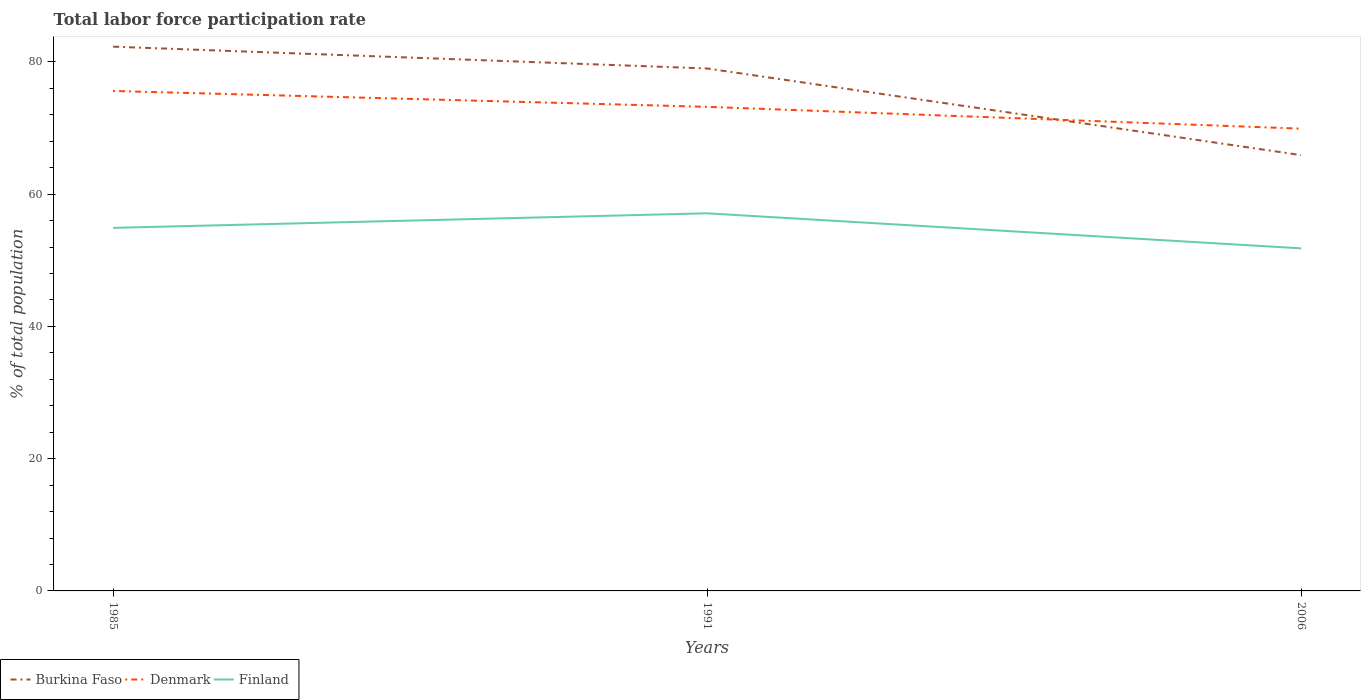Does the line corresponding to Burkina Faso intersect with the line corresponding to Finland?
Give a very brief answer. No. Across all years, what is the maximum total labor force participation rate in Finland?
Offer a very short reply. 51.8. In which year was the total labor force participation rate in Finland maximum?
Offer a very short reply. 2006. What is the total total labor force participation rate in Denmark in the graph?
Ensure brevity in your answer.  2.4. What is the difference between the highest and the second highest total labor force participation rate in Finland?
Provide a short and direct response. 5.3. Is the total labor force participation rate in Finland strictly greater than the total labor force participation rate in Denmark over the years?
Your answer should be very brief. Yes. What is the difference between two consecutive major ticks on the Y-axis?
Ensure brevity in your answer.  20. Does the graph contain grids?
Your response must be concise. No. Where does the legend appear in the graph?
Your answer should be compact. Bottom left. How many legend labels are there?
Your response must be concise. 3. How are the legend labels stacked?
Keep it short and to the point. Horizontal. What is the title of the graph?
Make the answer very short. Total labor force participation rate. What is the label or title of the Y-axis?
Give a very brief answer. % of total population. What is the % of total population of Burkina Faso in 1985?
Keep it short and to the point. 82.3. What is the % of total population of Denmark in 1985?
Give a very brief answer. 75.6. What is the % of total population of Finland in 1985?
Provide a short and direct response. 54.9. What is the % of total population in Burkina Faso in 1991?
Your answer should be very brief. 79. What is the % of total population in Denmark in 1991?
Your answer should be compact. 73.2. What is the % of total population of Finland in 1991?
Keep it short and to the point. 57.1. What is the % of total population of Burkina Faso in 2006?
Ensure brevity in your answer.  65.9. What is the % of total population in Denmark in 2006?
Keep it short and to the point. 69.9. What is the % of total population in Finland in 2006?
Provide a succinct answer. 51.8. Across all years, what is the maximum % of total population of Burkina Faso?
Your answer should be compact. 82.3. Across all years, what is the maximum % of total population in Denmark?
Provide a succinct answer. 75.6. Across all years, what is the maximum % of total population in Finland?
Provide a succinct answer. 57.1. Across all years, what is the minimum % of total population of Burkina Faso?
Provide a short and direct response. 65.9. Across all years, what is the minimum % of total population of Denmark?
Make the answer very short. 69.9. Across all years, what is the minimum % of total population in Finland?
Make the answer very short. 51.8. What is the total % of total population of Burkina Faso in the graph?
Offer a very short reply. 227.2. What is the total % of total population in Denmark in the graph?
Ensure brevity in your answer.  218.7. What is the total % of total population of Finland in the graph?
Your response must be concise. 163.8. What is the difference between the % of total population in Burkina Faso in 1985 and that in 1991?
Offer a terse response. 3.3. What is the difference between the % of total population in Burkina Faso in 1985 and that in 2006?
Your answer should be compact. 16.4. What is the difference between the % of total population of Denmark in 1985 and that in 2006?
Ensure brevity in your answer.  5.7. What is the difference between the % of total population in Finland in 1985 and that in 2006?
Give a very brief answer. 3.1. What is the difference between the % of total population of Burkina Faso in 1991 and that in 2006?
Ensure brevity in your answer.  13.1. What is the difference between the % of total population in Denmark in 1991 and that in 2006?
Offer a terse response. 3.3. What is the difference between the % of total population of Finland in 1991 and that in 2006?
Offer a very short reply. 5.3. What is the difference between the % of total population of Burkina Faso in 1985 and the % of total population of Denmark in 1991?
Give a very brief answer. 9.1. What is the difference between the % of total population in Burkina Faso in 1985 and the % of total population in Finland in 1991?
Offer a very short reply. 25.2. What is the difference between the % of total population of Burkina Faso in 1985 and the % of total population of Denmark in 2006?
Keep it short and to the point. 12.4. What is the difference between the % of total population of Burkina Faso in 1985 and the % of total population of Finland in 2006?
Provide a succinct answer. 30.5. What is the difference between the % of total population of Denmark in 1985 and the % of total population of Finland in 2006?
Ensure brevity in your answer.  23.8. What is the difference between the % of total population in Burkina Faso in 1991 and the % of total population in Denmark in 2006?
Provide a short and direct response. 9.1. What is the difference between the % of total population in Burkina Faso in 1991 and the % of total population in Finland in 2006?
Make the answer very short. 27.2. What is the difference between the % of total population of Denmark in 1991 and the % of total population of Finland in 2006?
Provide a succinct answer. 21.4. What is the average % of total population of Burkina Faso per year?
Keep it short and to the point. 75.73. What is the average % of total population in Denmark per year?
Provide a short and direct response. 72.9. What is the average % of total population in Finland per year?
Keep it short and to the point. 54.6. In the year 1985, what is the difference between the % of total population of Burkina Faso and % of total population of Denmark?
Your answer should be compact. 6.7. In the year 1985, what is the difference between the % of total population in Burkina Faso and % of total population in Finland?
Give a very brief answer. 27.4. In the year 1985, what is the difference between the % of total population in Denmark and % of total population in Finland?
Make the answer very short. 20.7. In the year 1991, what is the difference between the % of total population of Burkina Faso and % of total population of Finland?
Make the answer very short. 21.9. In the year 2006, what is the difference between the % of total population of Burkina Faso and % of total population of Finland?
Ensure brevity in your answer.  14.1. What is the ratio of the % of total population of Burkina Faso in 1985 to that in 1991?
Offer a very short reply. 1.04. What is the ratio of the % of total population of Denmark in 1985 to that in 1991?
Give a very brief answer. 1.03. What is the ratio of the % of total population in Finland in 1985 to that in 1991?
Your response must be concise. 0.96. What is the ratio of the % of total population of Burkina Faso in 1985 to that in 2006?
Provide a short and direct response. 1.25. What is the ratio of the % of total population of Denmark in 1985 to that in 2006?
Offer a very short reply. 1.08. What is the ratio of the % of total population in Finland in 1985 to that in 2006?
Offer a very short reply. 1.06. What is the ratio of the % of total population of Burkina Faso in 1991 to that in 2006?
Offer a very short reply. 1.2. What is the ratio of the % of total population of Denmark in 1991 to that in 2006?
Offer a terse response. 1.05. What is the ratio of the % of total population in Finland in 1991 to that in 2006?
Your answer should be very brief. 1.1. What is the difference between the highest and the second highest % of total population of Burkina Faso?
Ensure brevity in your answer.  3.3. What is the difference between the highest and the second highest % of total population in Denmark?
Keep it short and to the point. 2.4. What is the difference between the highest and the second highest % of total population of Finland?
Provide a succinct answer. 2.2. 